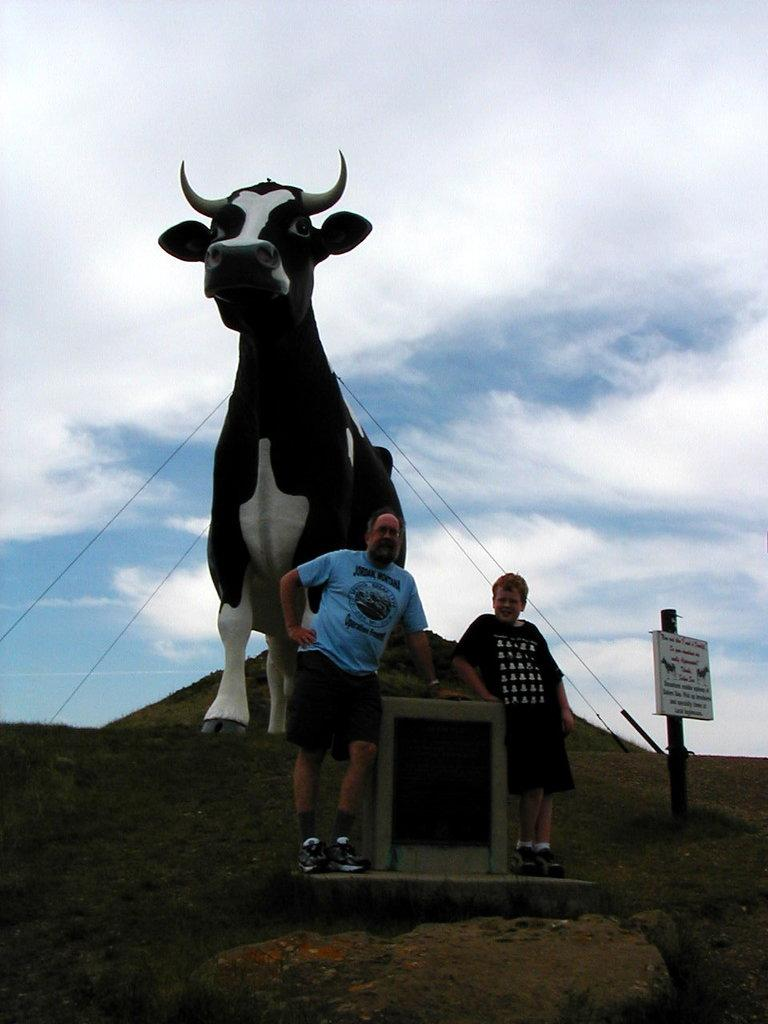How many people are present in the image? There are two persons standing in the image. What objects can be seen in the image besides the people? There is a board, a pole, and an animal statue in the image. What is visible in the background of the image? The sky with clouds is visible in the background of the image. What type of lettuce is growing on the pole in the image? There is no lettuce present in the image; it features a pole and other objects, but not lettuce. Can you tell me how many snakes are wrapped around the animal statue in the image? There are no snakes present in the image; the animal statue is the only animal depicted. 